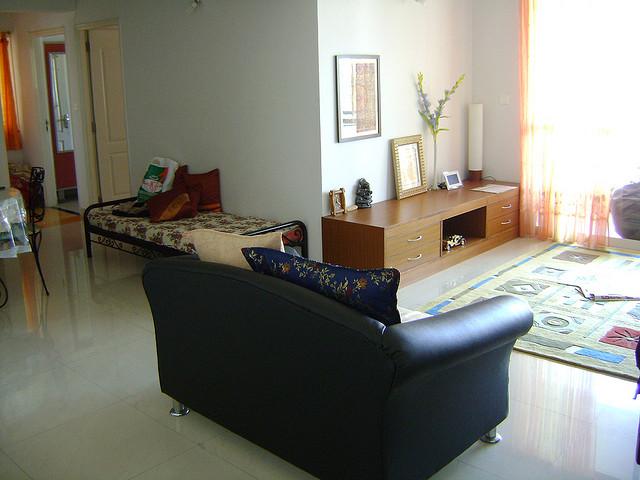How many framed objects?
Be succinct. 4. What color are the walls?
Concise answer only. White. Where is the black loveseat?
Be succinct. Living room. 